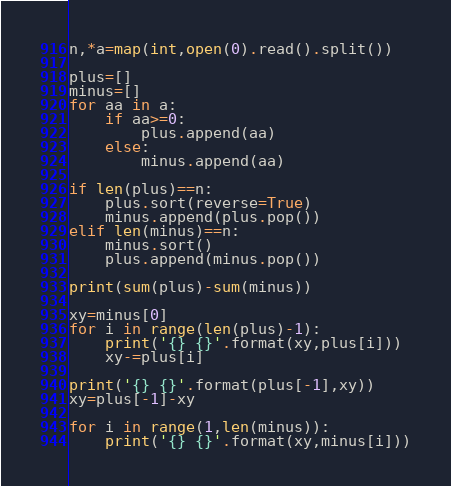<code> <loc_0><loc_0><loc_500><loc_500><_Python_>n,*a=map(int,open(0).read().split())

plus=[]
minus=[]
for aa in a:
    if aa>=0:
        plus.append(aa)
    else:
        minus.append(aa)

if len(plus)==n:
    plus.sort(reverse=True)
    minus.append(plus.pop())
elif len(minus)==n:
    minus.sort()
    plus.append(minus.pop())

print(sum(plus)-sum(minus))

xy=minus[0]
for i in range(len(plus)-1):
    print('{} {}'.format(xy,plus[i]))
    xy-=plus[i]

print('{} {}'.format(plus[-1],xy))
xy=plus[-1]-xy

for i in range(1,len(minus)):
    print('{} {}'.format(xy,minus[i]))

</code> 